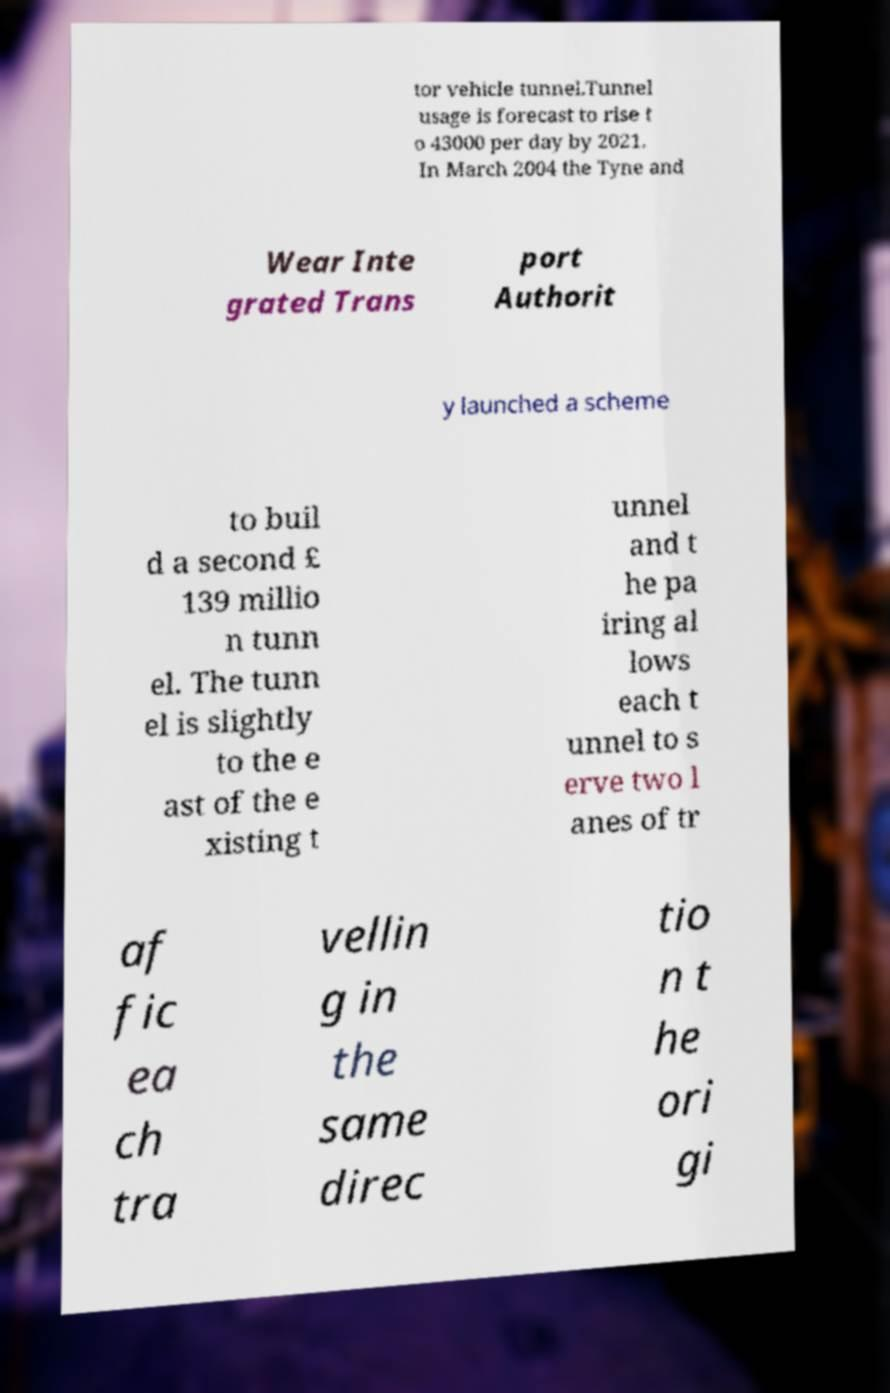Please identify and transcribe the text found in this image. tor vehicle tunnel.Tunnel usage is forecast to rise t o 43000 per day by 2021. In March 2004 the Tyne and Wear Inte grated Trans port Authorit y launched a scheme to buil d a second £ 139 millio n tunn el. The tunn el is slightly to the e ast of the e xisting t unnel and t he pa iring al lows each t unnel to s erve two l anes of tr af fic ea ch tra vellin g in the same direc tio n t he ori gi 